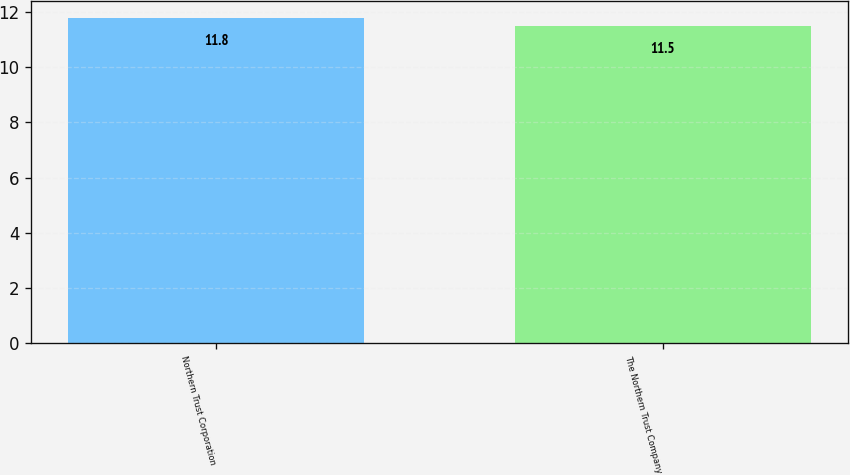Convert chart to OTSL. <chart><loc_0><loc_0><loc_500><loc_500><bar_chart><fcel>Northern Trust Corporation<fcel>The Northern Trust Company<nl><fcel>11.8<fcel>11.5<nl></chart> 